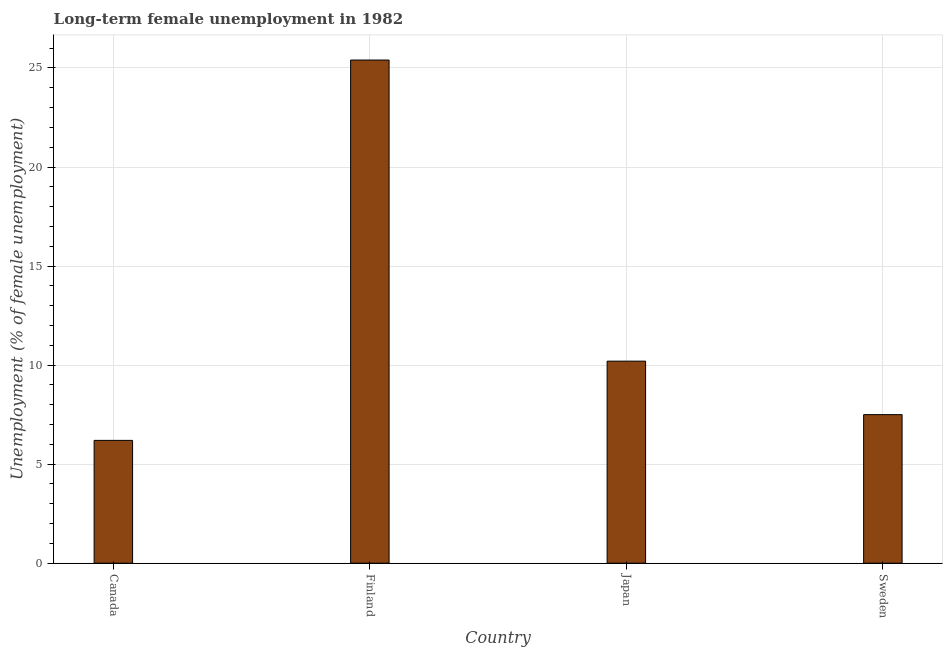What is the title of the graph?
Provide a short and direct response. Long-term female unemployment in 1982. What is the label or title of the X-axis?
Offer a very short reply. Country. What is the label or title of the Y-axis?
Provide a short and direct response. Unemployment (% of female unemployment). What is the long-term female unemployment in Finland?
Ensure brevity in your answer.  25.4. Across all countries, what is the maximum long-term female unemployment?
Provide a short and direct response. 25.4. Across all countries, what is the minimum long-term female unemployment?
Your answer should be very brief. 6.2. In which country was the long-term female unemployment maximum?
Give a very brief answer. Finland. In which country was the long-term female unemployment minimum?
Ensure brevity in your answer.  Canada. What is the sum of the long-term female unemployment?
Make the answer very short. 49.3. What is the average long-term female unemployment per country?
Offer a terse response. 12.32. What is the median long-term female unemployment?
Your answer should be very brief. 8.85. In how many countries, is the long-term female unemployment greater than 1 %?
Offer a very short reply. 4. What is the ratio of the long-term female unemployment in Finland to that in Japan?
Give a very brief answer. 2.49. What is the difference between the highest and the second highest long-term female unemployment?
Provide a succinct answer. 15.2. Is the sum of the long-term female unemployment in Finland and Sweden greater than the maximum long-term female unemployment across all countries?
Offer a very short reply. Yes. In how many countries, is the long-term female unemployment greater than the average long-term female unemployment taken over all countries?
Give a very brief answer. 1. How many bars are there?
Offer a very short reply. 4. Are all the bars in the graph horizontal?
Offer a terse response. No. How many countries are there in the graph?
Keep it short and to the point. 4. What is the difference between two consecutive major ticks on the Y-axis?
Offer a terse response. 5. Are the values on the major ticks of Y-axis written in scientific E-notation?
Keep it short and to the point. No. What is the Unemployment (% of female unemployment) in Canada?
Your answer should be compact. 6.2. What is the Unemployment (% of female unemployment) of Finland?
Your response must be concise. 25.4. What is the Unemployment (% of female unemployment) of Japan?
Offer a very short reply. 10.2. What is the difference between the Unemployment (% of female unemployment) in Canada and Finland?
Ensure brevity in your answer.  -19.2. What is the difference between the Unemployment (% of female unemployment) in Canada and Japan?
Your answer should be very brief. -4. What is the difference between the Unemployment (% of female unemployment) in Finland and Sweden?
Make the answer very short. 17.9. What is the ratio of the Unemployment (% of female unemployment) in Canada to that in Finland?
Offer a terse response. 0.24. What is the ratio of the Unemployment (% of female unemployment) in Canada to that in Japan?
Your answer should be compact. 0.61. What is the ratio of the Unemployment (% of female unemployment) in Canada to that in Sweden?
Provide a short and direct response. 0.83. What is the ratio of the Unemployment (% of female unemployment) in Finland to that in Japan?
Your answer should be very brief. 2.49. What is the ratio of the Unemployment (% of female unemployment) in Finland to that in Sweden?
Keep it short and to the point. 3.39. What is the ratio of the Unemployment (% of female unemployment) in Japan to that in Sweden?
Your answer should be very brief. 1.36. 